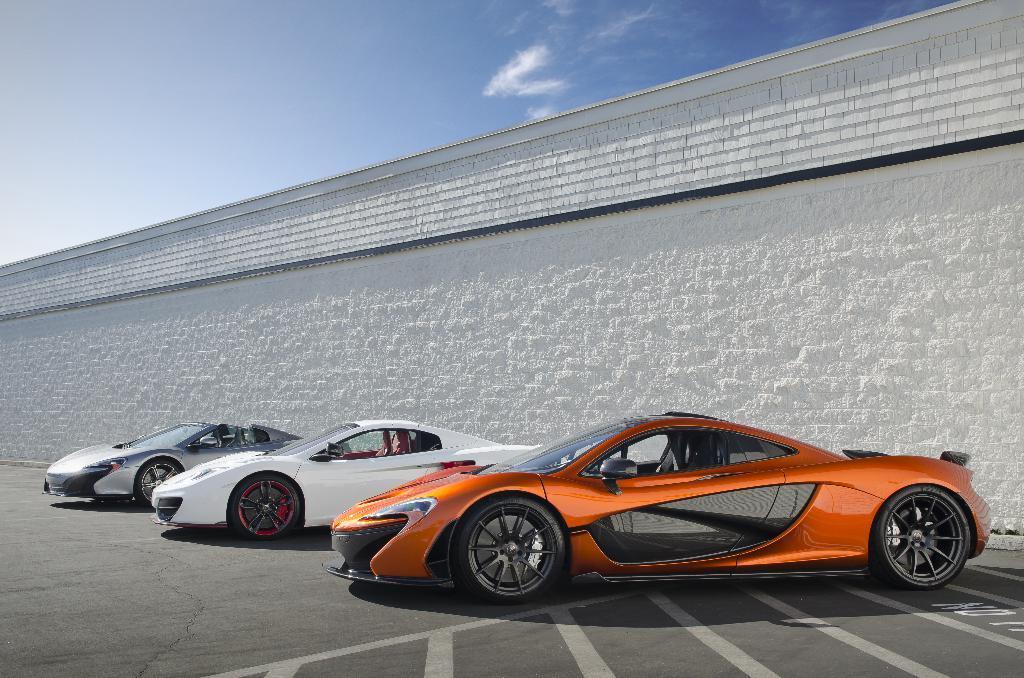How would you summarize this image in a sentence or two? In this image we can see three cars on the road and white color wall and the sky at the top. 